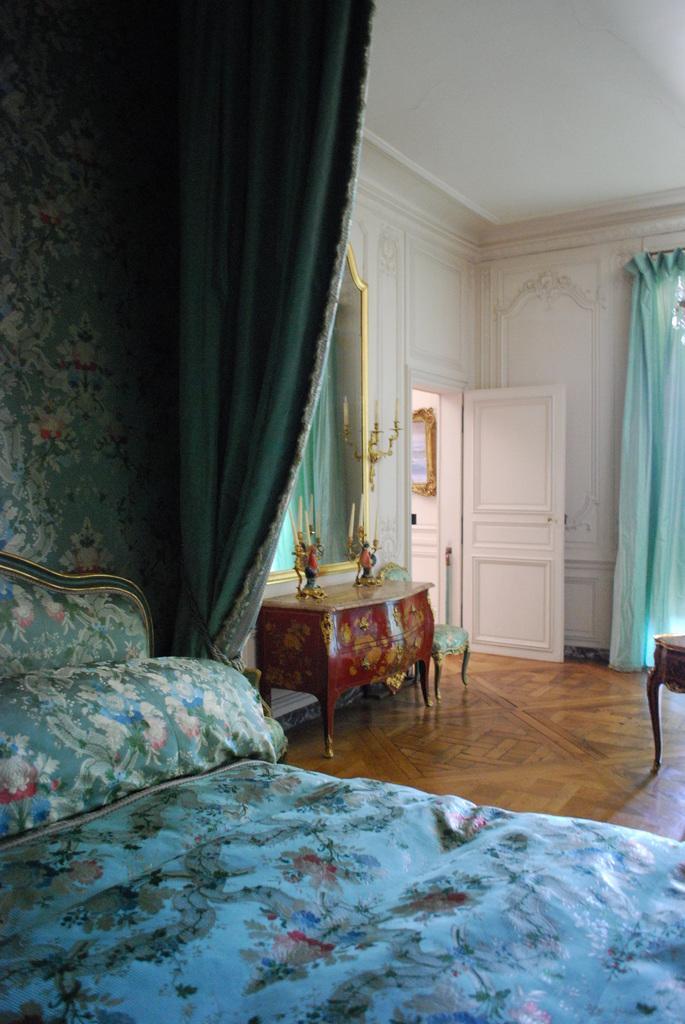How would you summarize this image in a sentence or two? In the center of the image there is a bed. In the background of the image there is a door. At the top of the image there is a ceiling. There is a table. There are curtains. 